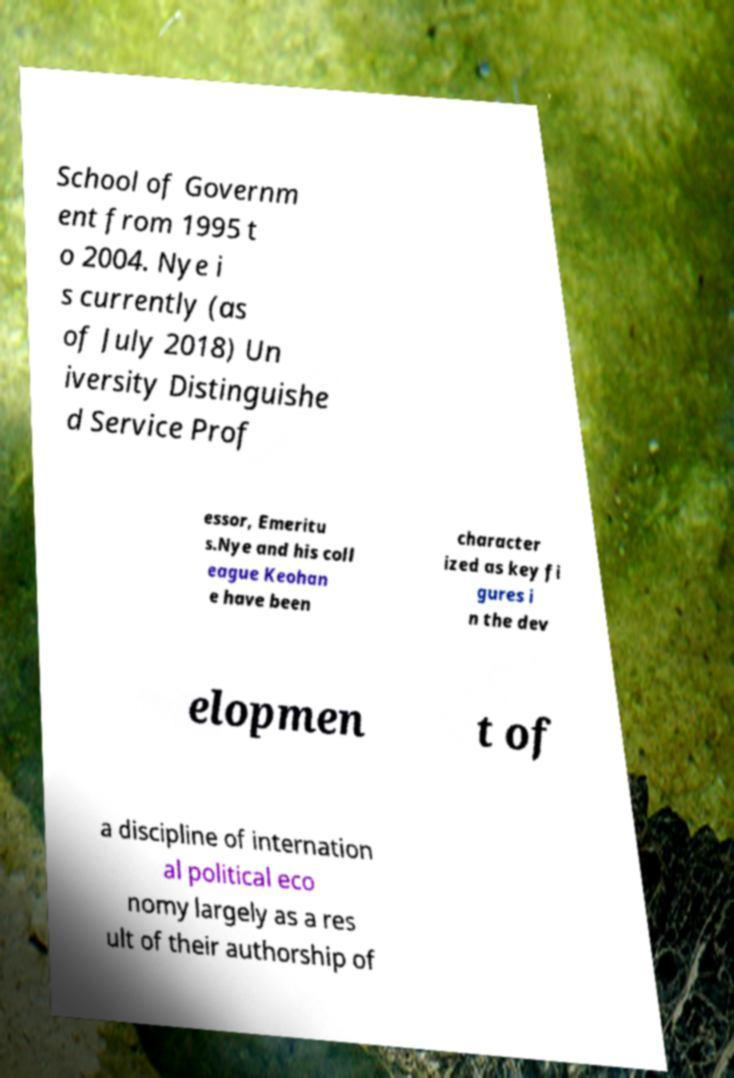Please identify and transcribe the text found in this image. School of Governm ent from 1995 t o 2004. Nye i s currently (as of July 2018) Un iversity Distinguishe d Service Prof essor, Emeritu s.Nye and his coll eague Keohan e have been character ized as key fi gures i n the dev elopmen t of a discipline of internation al political eco nomy largely as a res ult of their authorship of 